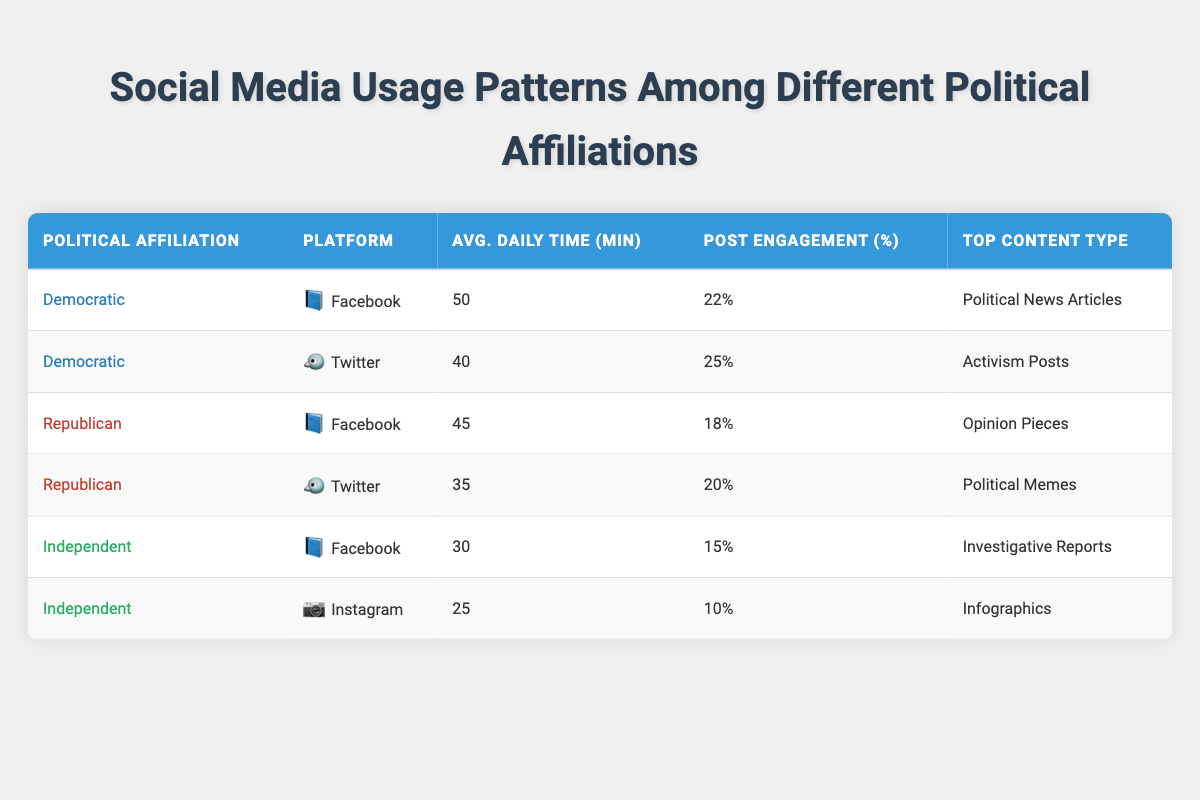What is the average daily time spent on Facebook by Democratic users? From the table, the average daily time spent on Facebook by Democratic users is listed as 50 minutes.
Answer: 50 minutes Which political affiliation has the highest post engagement percentage on Twitter? The table shows that the Democratic political affiliation has a post engagement percentage of 25% on Twitter, which is higher than the Republican's 20%.
Answer: Democratic Calculate the total average daily time spent by Independent users across Facebook and Instagram. The average daily time spent by Independent users on Facebook is 30 minutes and on Instagram is 25 minutes. Adding these together gives 30 + 25 = 55 minutes.
Answer: 55 minutes Is it true that Republican users spend more time on Facebook than Independent users? According to the table, Republican users spend 45 minutes on Facebook while Independent users spend 30 minutes. Since 45 is greater than 30, the statement is true.
Answer: Yes What is the difference in average daily time spent on Twitter between Democrats and Republicans? The average daily time spent by Democrats on Twitter is 40 minutes, while Republicans spend 35 minutes. To find the difference, subtract the Republican usage from the Democratic usage: 40 - 35 = 5 minutes.
Answer: 5 minutes Which political affiliation shows the least average daily time spent on social media? The average daily time spent is 30 minutes for Independents on Facebook and 25 minutes on Instagram; both are lower than the times spent by Democrats and Republicans. Therefore, Independents have the least overall time.
Answer: Independent 